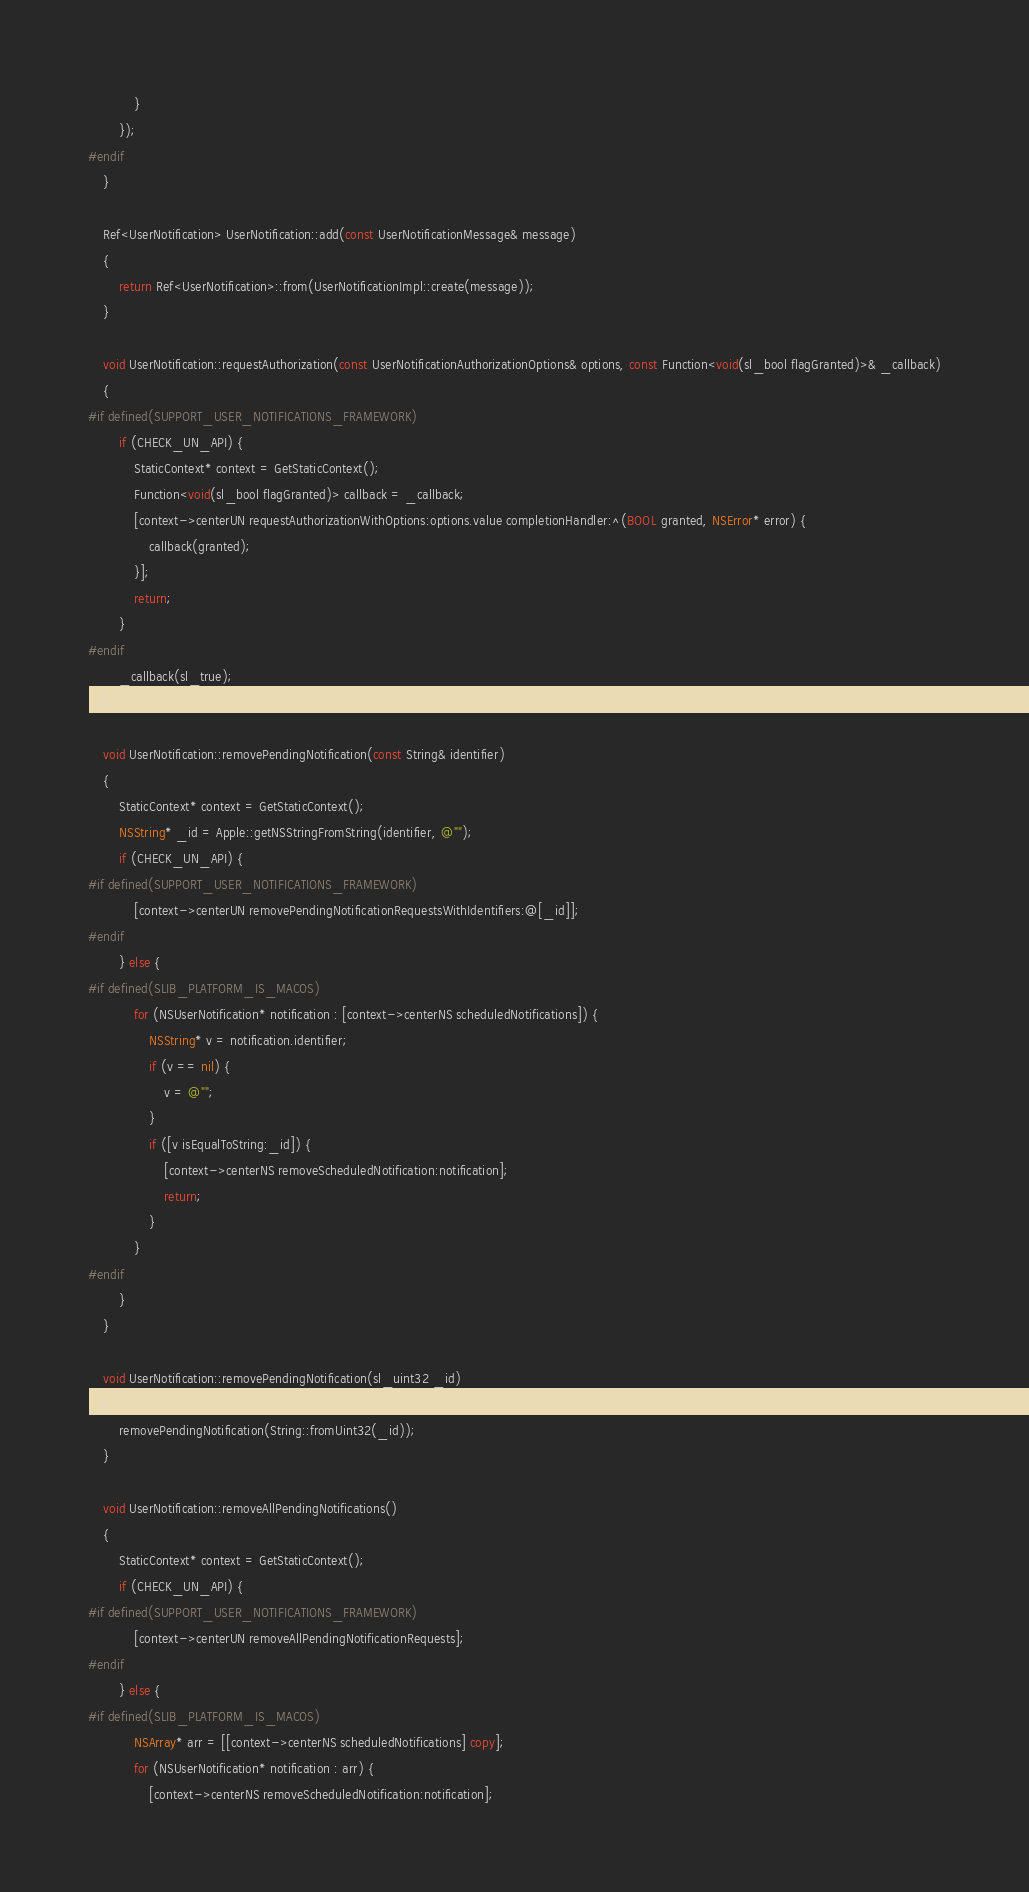Convert code to text. <code><loc_0><loc_0><loc_500><loc_500><_ObjectiveC_>			}
		});
#endif
	}

	Ref<UserNotification> UserNotification::add(const UserNotificationMessage& message)
	{
		return Ref<UserNotification>::from(UserNotificationImpl::create(message));
	}

	void UserNotification::requestAuthorization(const UserNotificationAuthorizationOptions& options, const Function<void(sl_bool flagGranted)>& _callback)
	{
#if defined(SUPPORT_USER_NOTIFICATIONS_FRAMEWORK)
		if (CHECK_UN_API) {
			StaticContext* context = GetStaticContext();
			Function<void(sl_bool flagGranted)> callback = _callback;
			[context->centerUN requestAuthorizationWithOptions:options.value completionHandler:^(BOOL granted, NSError* error) {
				callback(granted);
			}];
			return;
		}
#endif
		_callback(sl_true);
	}

	void UserNotification::removePendingNotification(const String& identifier)
	{
		StaticContext* context = GetStaticContext();
		NSString* _id = Apple::getNSStringFromString(identifier, @"");
		if (CHECK_UN_API) {
#if defined(SUPPORT_USER_NOTIFICATIONS_FRAMEWORK)
			[context->centerUN removePendingNotificationRequestsWithIdentifiers:@[_id]];
#endif
		} else {
#if defined(SLIB_PLATFORM_IS_MACOS)
			for (NSUserNotification* notification : [context->centerNS scheduledNotifications]) {
				NSString* v = notification.identifier;
				if (v == nil) {
					v = @"";
				}
				if ([v isEqualToString:_id]) {
					[context->centerNS removeScheduledNotification:notification];
					return;
				}
			}
#endif
		}
	}
	
	void UserNotification::removePendingNotification(sl_uint32 _id)
	{
		removePendingNotification(String::fromUint32(_id));
	}

	void UserNotification::removeAllPendingNotifications()
	{
		StaticContext* context = GetStaticContext();
		if (CHECK_UN_API) {
#if defined(SUPPORT_USER_NOTIFICATIONS_FRAMEWORK)
			[context->centerUN removeAllPendingNotificationRequests];
#endif
		} else {
#if defined(SLIB_PLATFORM_IS_MACOS)
			NSArray* arr = [[context->centerNS scheduledNotifications] copy];
			for (NSUserNotification* notification : arr) {
				[context->centerNS removeScheduledNotification:notification];</code> 